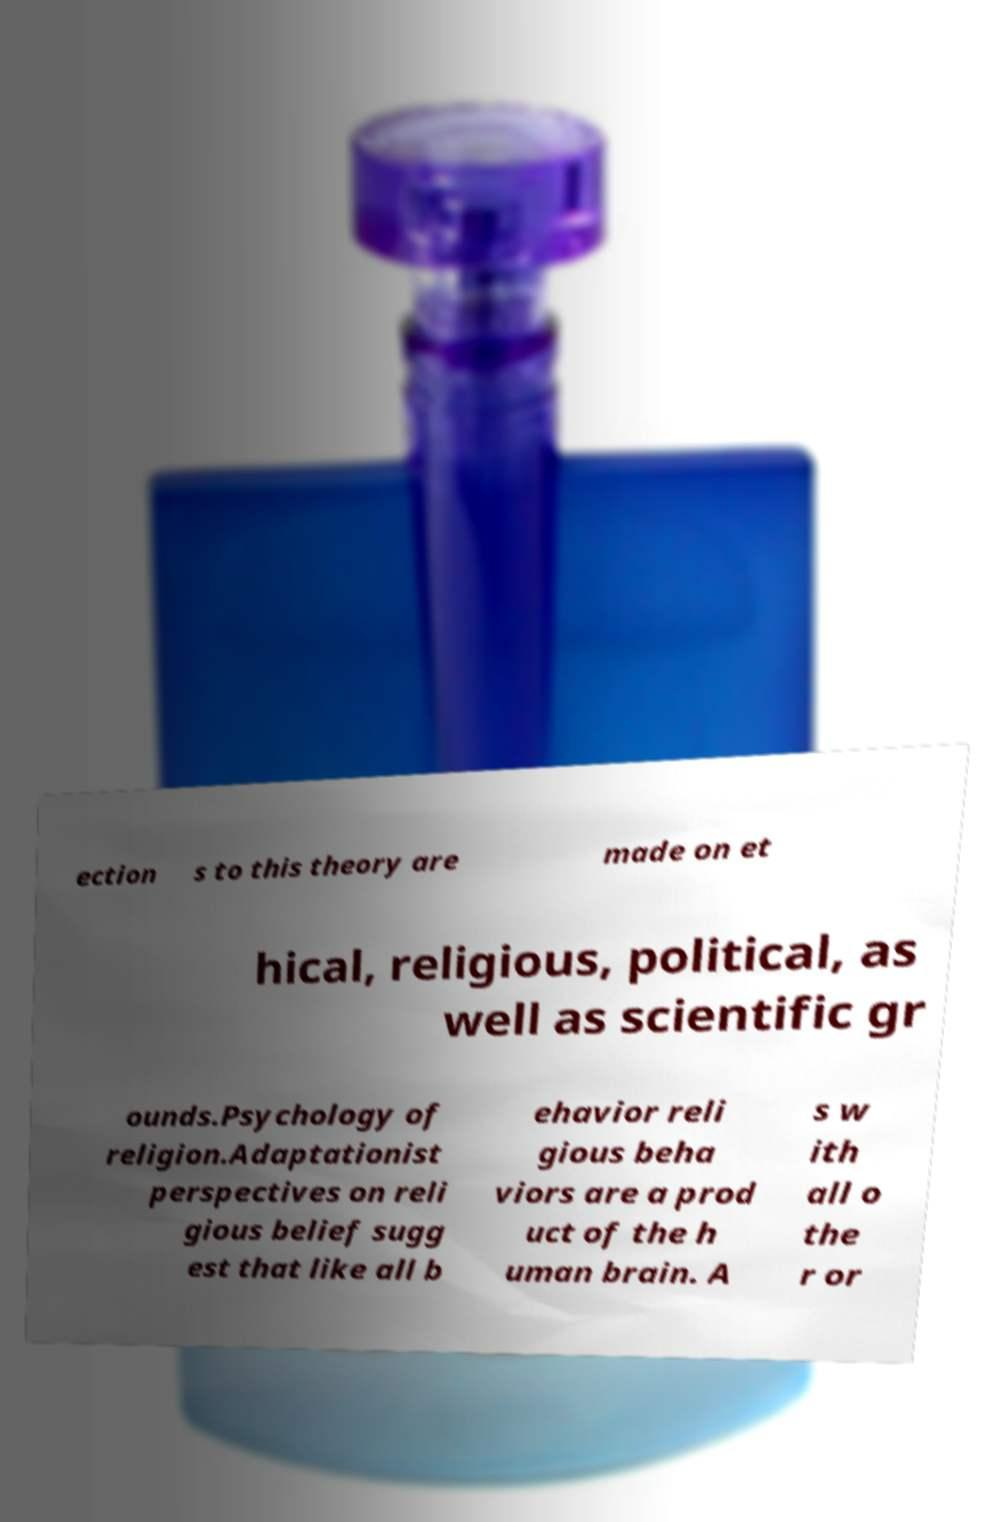Could you extract and type out the text from this image? ection s to this theory are made on et hical, religious, political, as well as scientific gr ounds.Psychology of religion.Adaptationist perspectives on reli gious belief sugg est that like all b ehavior reli gious beha viors are a prod uct of the h uman brain. A s w ith all o the r or 